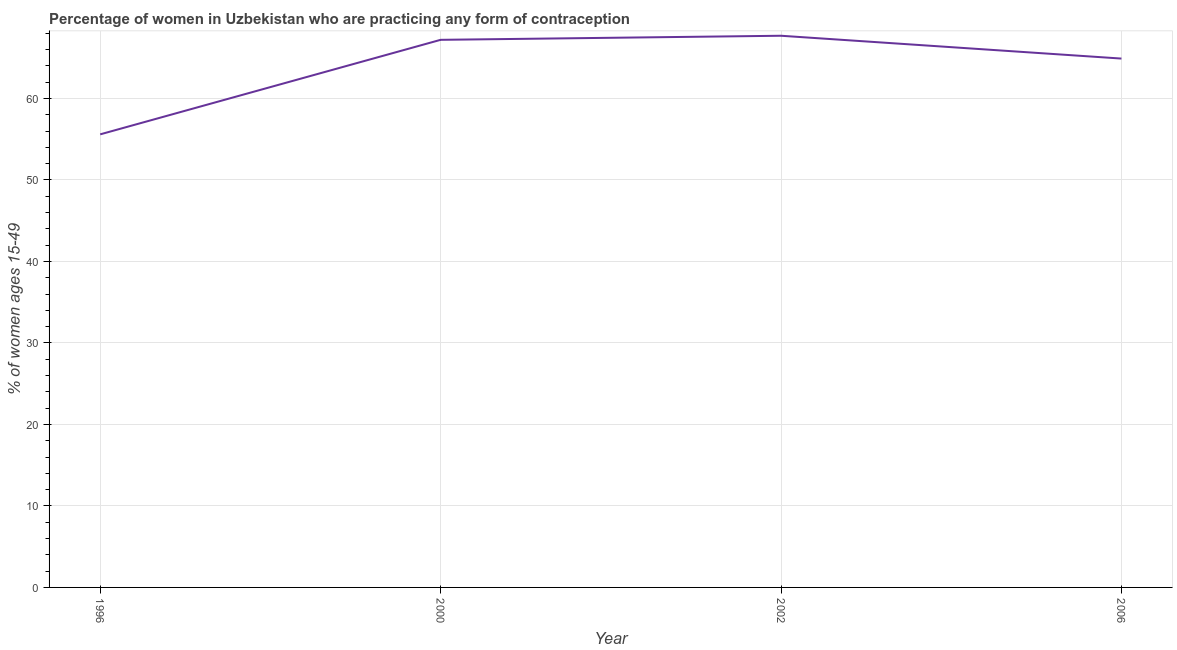What is the contraceptive prevalence in 1996?
Give a very brief answer. 55.6. Across all years, what is the maximum contraceptive prevalence?
Make the answer very short. 67.7. Across all years, what is the minimum contraceptive prevalence?
Your answer should be very brief. 55.6. In which year was the contraceptive prevalence minimum?
Your response must be concise. 1996. What is the sum of the contraceptive prevalence?
Keep it short and to the point. 255.4. What is the difference between the contraceptive prevalence in 2002 and 2006?
Offer a very short reply. 2.8. What is the average contraceptive prevalence per year?
Your answer should be very brief. 63.85. What is the median contraceptive prevalence?
Provide a short and direct response. 66.05. What is the ratio of the contraceptive prevalence in 1996 to that in 2002?
Your answer should be compact. 0.82. What is the difference between the highest and the second highest contraceptive prevalence?
Offer a very short reply. 0.5. What is the difference between the highest and the lowest contraceptive prevalence?
Ensure brevity in your answer.  12.1. Does the contraceptive prevalence monotonically increase over the years?
Make the answer very short. No. How many years are there in the graph?
Offer a very short reply. 4. Does the graph contain any zero values?
Your answer should be very brief. No. What is the title of the graph?
Keep it short and to the point. Percentage of women in Uzbekistan who are practicing any form of contraception. What is the label or title of the Y-axis?
Offer a terse response. % of women ages 15-49. What is the % of women ages 15-49 of 1996?
Your answer should be compact. 55.6. What is the % of women ages 15-49 of 2000?
Your response must be concise. 67.2. What is the % of women ages 15-49 of 2002?
Offer a terse response. 67.7. What is the % of women ages 15-49 of 2006?
Offer a very short reply. 64.9. What is the difference between the % of women ages 15-49 in 1996 and 2000?
Your response must be concise. -11.6. What is the difference between the % of women ages 15-49 in 1996 and 2002?
Offer a terse response. -12.1. What is the difference between the % of women ages 15-49 in 2000 and 2006?
Your response must be concise. 2.3. What is the difference between the % of women ages 15-49 in 2002 and 2006?
Your response must be concise. 2.8. What is the ratio of the % of women ages 15-49 in 1996 to that in 2000?
Make the answer very short. 0.83. What is the ratio of the % of women ages 15-49 in 1996 to that in 2002?
Your answer should be compact. 0.82. What is the ratio of the % of women ages 15-49 in 1996 to that in 2006?
Provide a succinct answer. 0.86. What is the ratio of the % of women ages 15-49 in 2000 to that in 2006?
Keep it short and to the point. 1.03. What is the ratio of the % of women ages 15-49 in 2002 to that in 2006?
Provide a short and direct response. 1.04. 